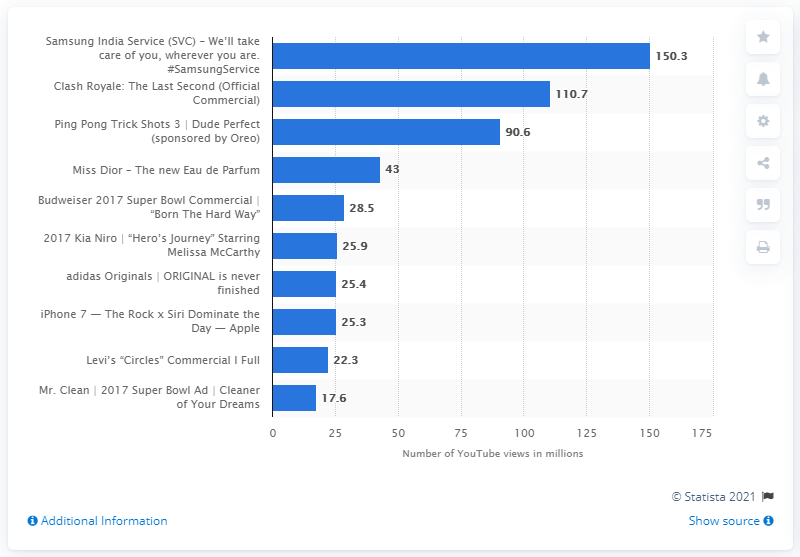Mention a couple of crucial points in this snapshot. The trailer for Apple's iPhone 7 featuring The Rock received 25,400 views. It is reported that Dior's ad for Miss Dior generated 43 views. 